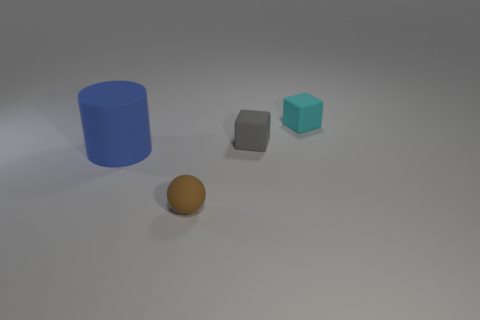What color is the small rubber cube that is left of the tiny cyan cube?
Offer a very short reply. Gray. How many small objects are the same color as the big thing?
Give a very brief answer. 0. There is a brown matte object; is it the same size as the matte object that is on the left side of the small brown thing?
Your answer should be compact. No. There is a object that is left of the tiny thing that is in front of the matte object that is to the left of the small brown ball; what is its size?
Ensure brevity in your answer.  Large. There is a tiny matte sphere; how many tiny matte spheres are behind it?
Give a very brief answer. 0. What material is the thing left of the tiny object that is in front of the large matte object?
Provide a short and direct response. Rubber. Are there any other things that are the same size as the gray matte object?
Provide a short and direct response. Yes. Is the matte cylinder the same size as the brown rubber thing?
Give a very brief answer. No. What number of things are matte things on the right side of the gray rubber cube or matte objects that are on the left side of the cyan matte cube?
Keep it short and to the point. 4. Is the number of brown matte objects that are on the left side of the big blue matte thing greater than the number of big blue rubber things?
Make the answer very short. No. 